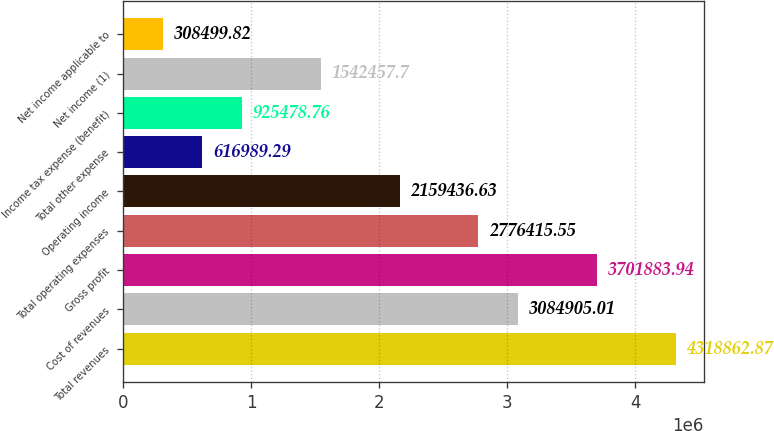<chart> <loc_0><loc_0><loc_500><loc_500><bar_chart><fcel>Total revenues<fcel>Cost of revenues<fcel>Gross profit<fcel>Total operating expenses<fcel>Operating income<fcel>Total other expense<fcel>Income tax expense (benefit)<fcel>Net income (1)<fcel>Net income applicable to<nl><fcel>4.31886e+06<fcel>3.08491e+06<fcel>3.70188e+06<fcel>2.77642e+06<fcel>2.15944e+06<fcel>616989<fcel>925479<fcel>1.54246e+06<fcel>308500<nl></chart> 